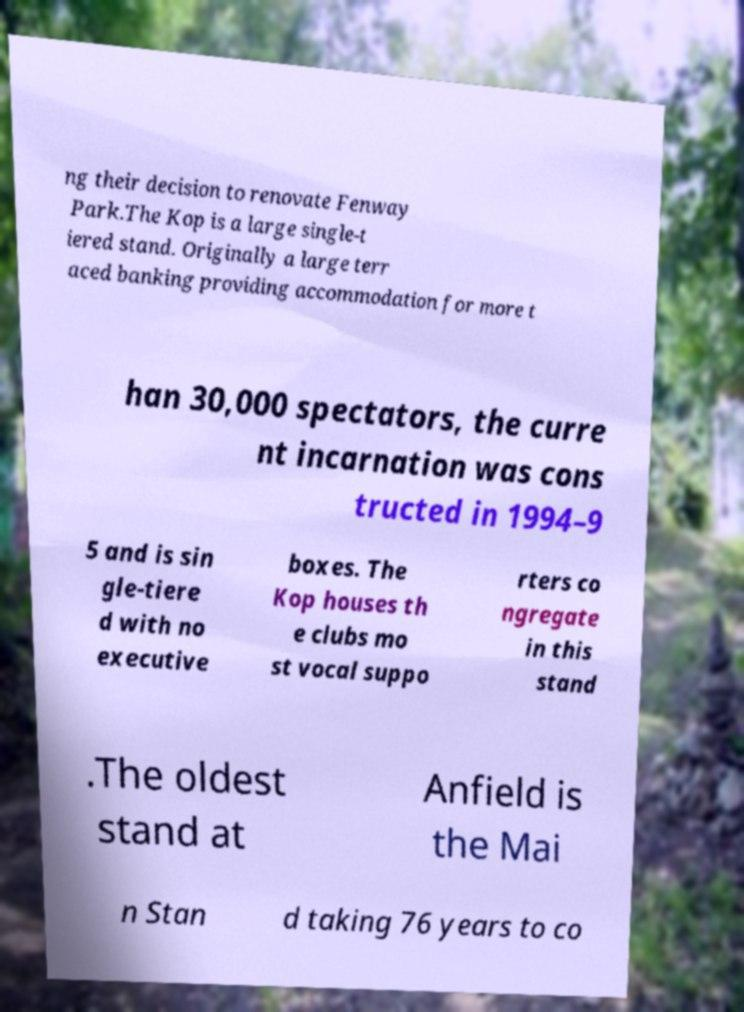For documentation purposes, I need the text within this image transcribed. Could you provide that? ng their decision to renovate Fenway Park.The Kop is a large single-t iered stand. Originally a large terr aced banking providing accommodation for more t han 30,000 spectators, the curre nt incarnation was cons tructed in 1994–9 5 and is sin gle-tiere d with no executive boxes. The Kop houses th e clubs mo st vocal suppo rters co ngregate in this stand .The oldest stand at Anfield is the Mai n Stan d taking 76 years to co 